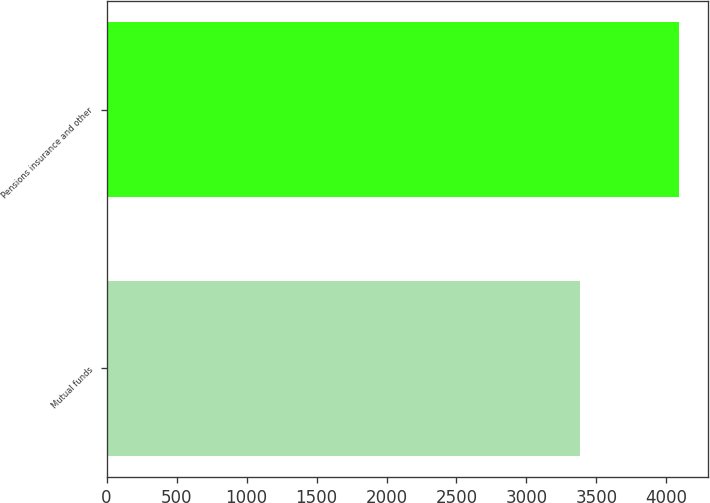Convert chart. <chart><loc_0><loc_0><loc_500><loc_500><bar_chart><fcel>Mutual funds<fcel>Pensions insurance and other<nl><fcel>3385<fcel>4093<nl></chart> 